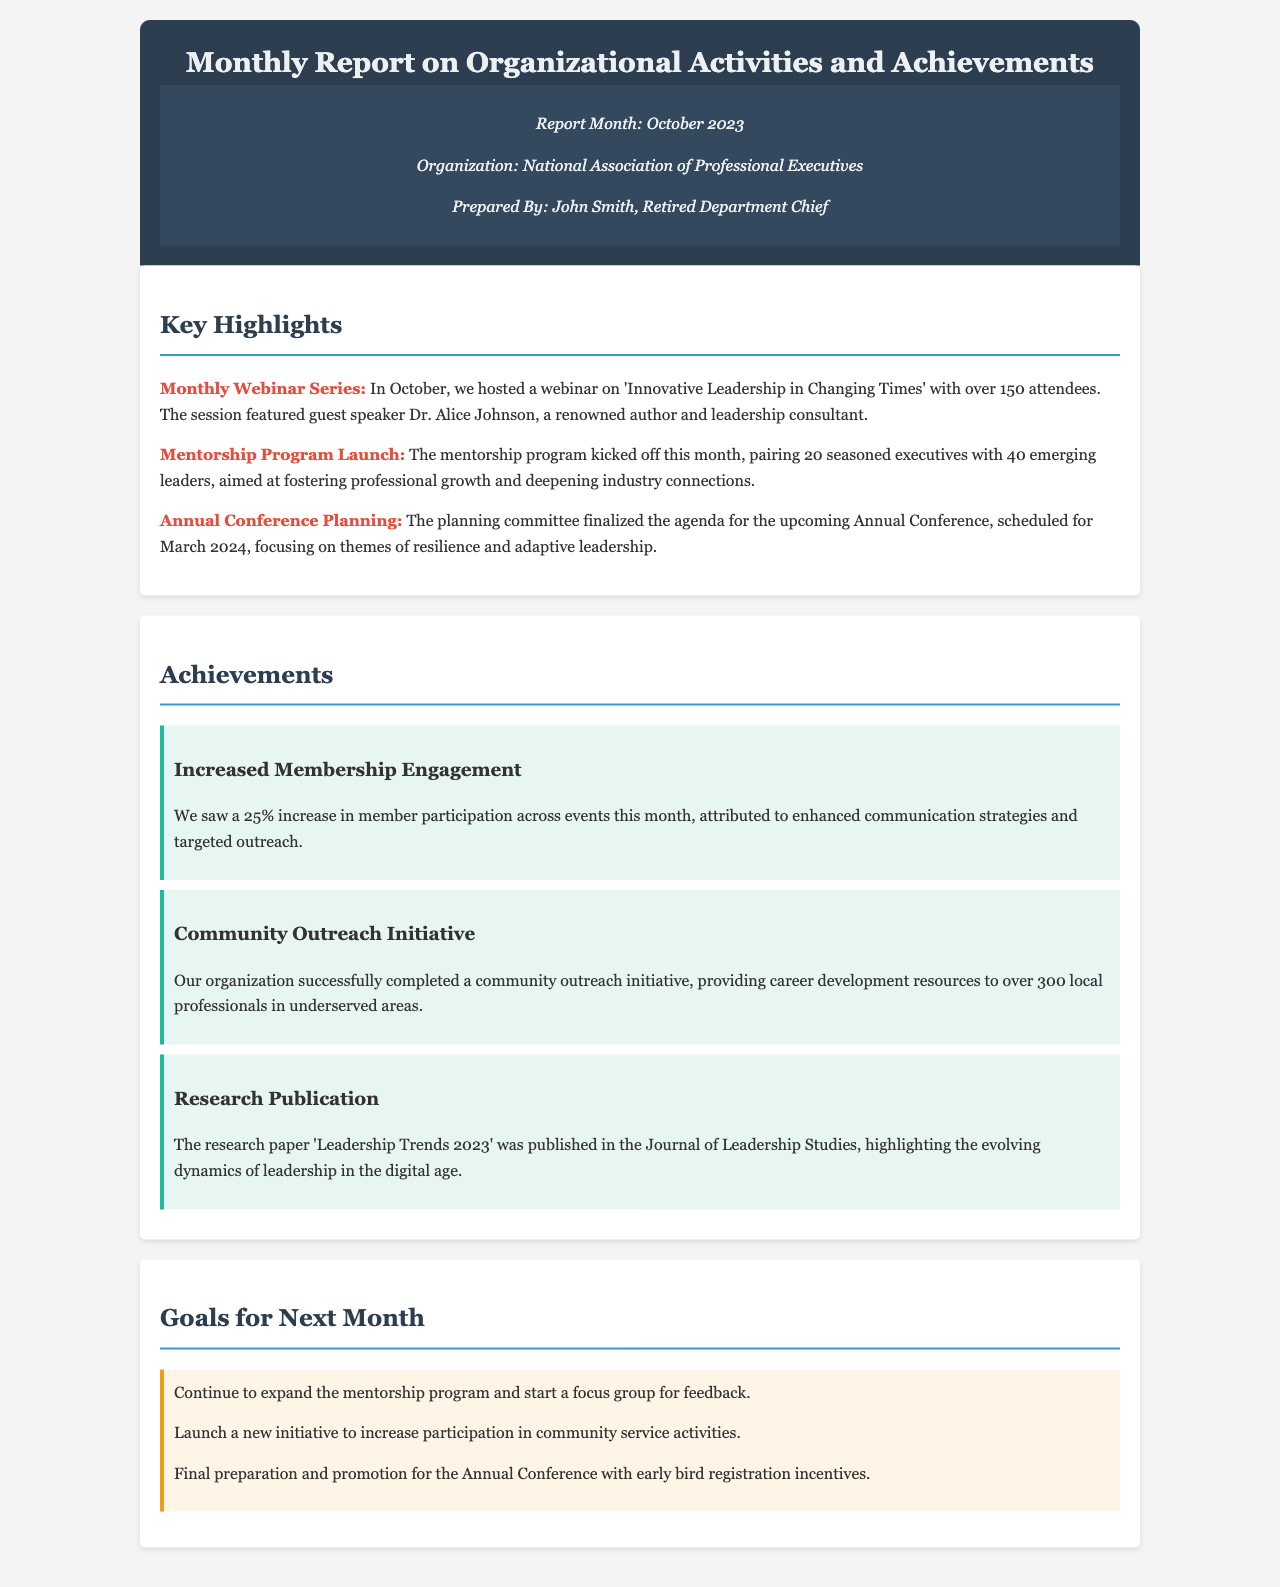What is the report month? The report month is stated in the report details section.
Answer: October 2023 Who prepared the report? The prepared by section specifies the individual responsible for the report.
Answer: John Smith How many attendees were at the monthly webinar? The number of attendees is mentioned in the key highlights of the document.
Answer: 150 What percentage increase in member participation was reported? This information is included in the achievements section regarding membership engagement.
Answer: 25% How many seasoned executives are paired with emerging leaders in the mentorship program? The number of seasoned executives is detailed in the mentorship program launch highlight.
Answer: 20 What is the theme for the upcoming Annual Conference? The theme for the conference is discussed in the planning section of key highlights.
Answer: Resilience and adaptive leadership How many local professionals received career development resources? This information is provided in the community outreach initiative achievement.
Answer: 300 What initiative is planned to increase participation in community service activities? The goals section outlines the initiative for next month.
Answer: New initiative What is the title of the published research paper? The title can be found in the achievements section about the research publication.
Answer: Leadership Trends 2023 